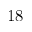<formula> <loc_0><loc_0><loc_500><loc_500>1 8</formula> 